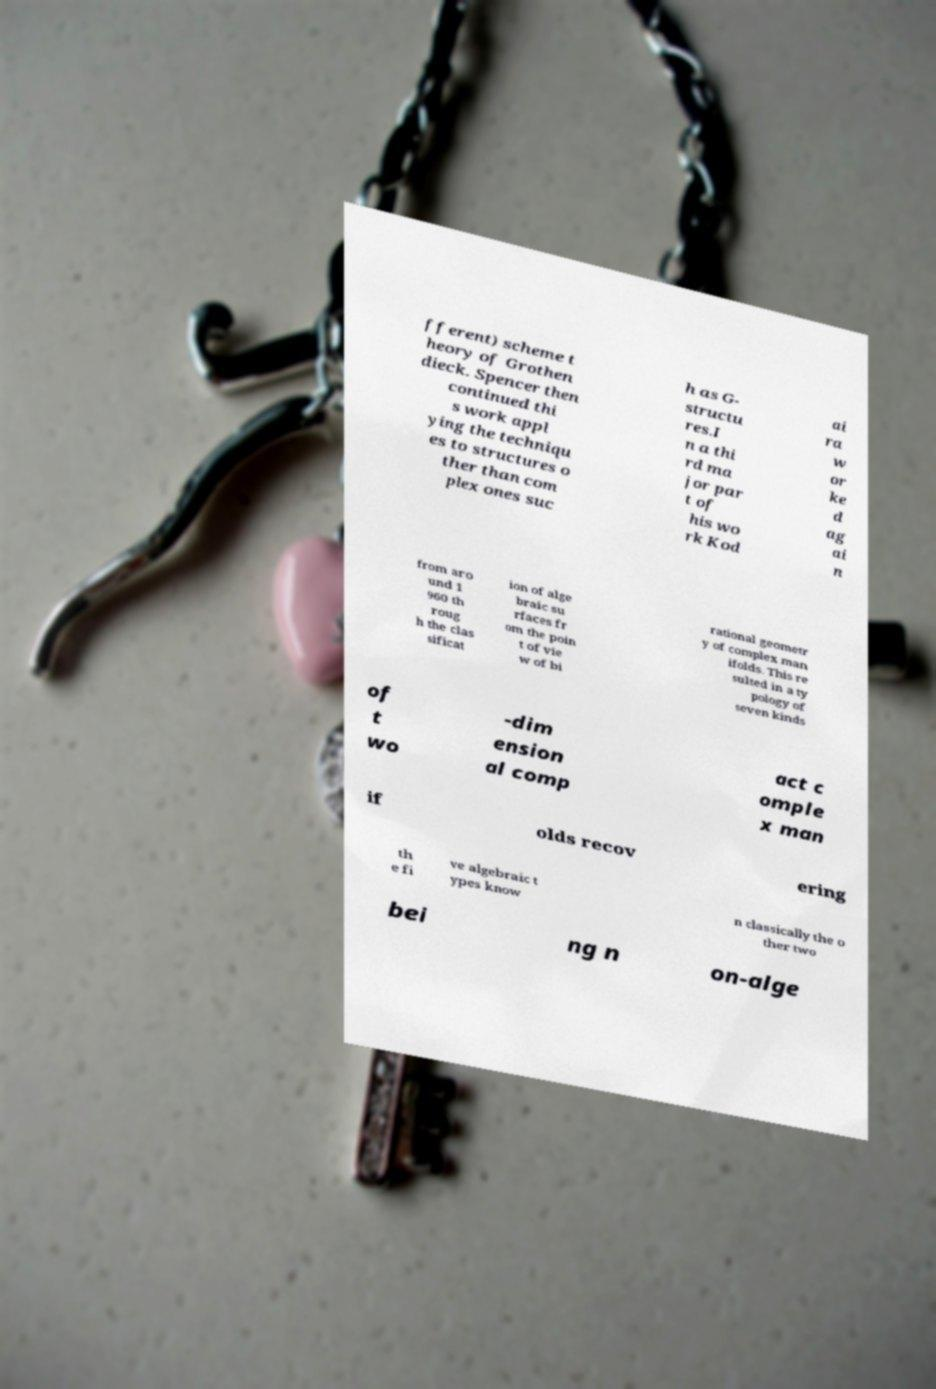Could you extract and type out the text from this image? fferent) scheme t heory of Grothen dieck. Spencer then continued thi s work appl ying the techniqu es to structures o ther than com plex ones suc h as G- structu res.I n a thi rd ma jor par t of his wo rk Kod ai ra w or ke d ag ai n from aro und 1 960 th roug h the clas sificat ion of alge braic su rfaces fr om the poin t of vie w of bi rational geometr y of complex man ifolds. This re sulted in a ty pology of seven kinds of t wo -dim ension al comp act c omple x man if olds recov ering th e fi ve algebraic t ypes know n classically the o ther two bei ng n on-alge 